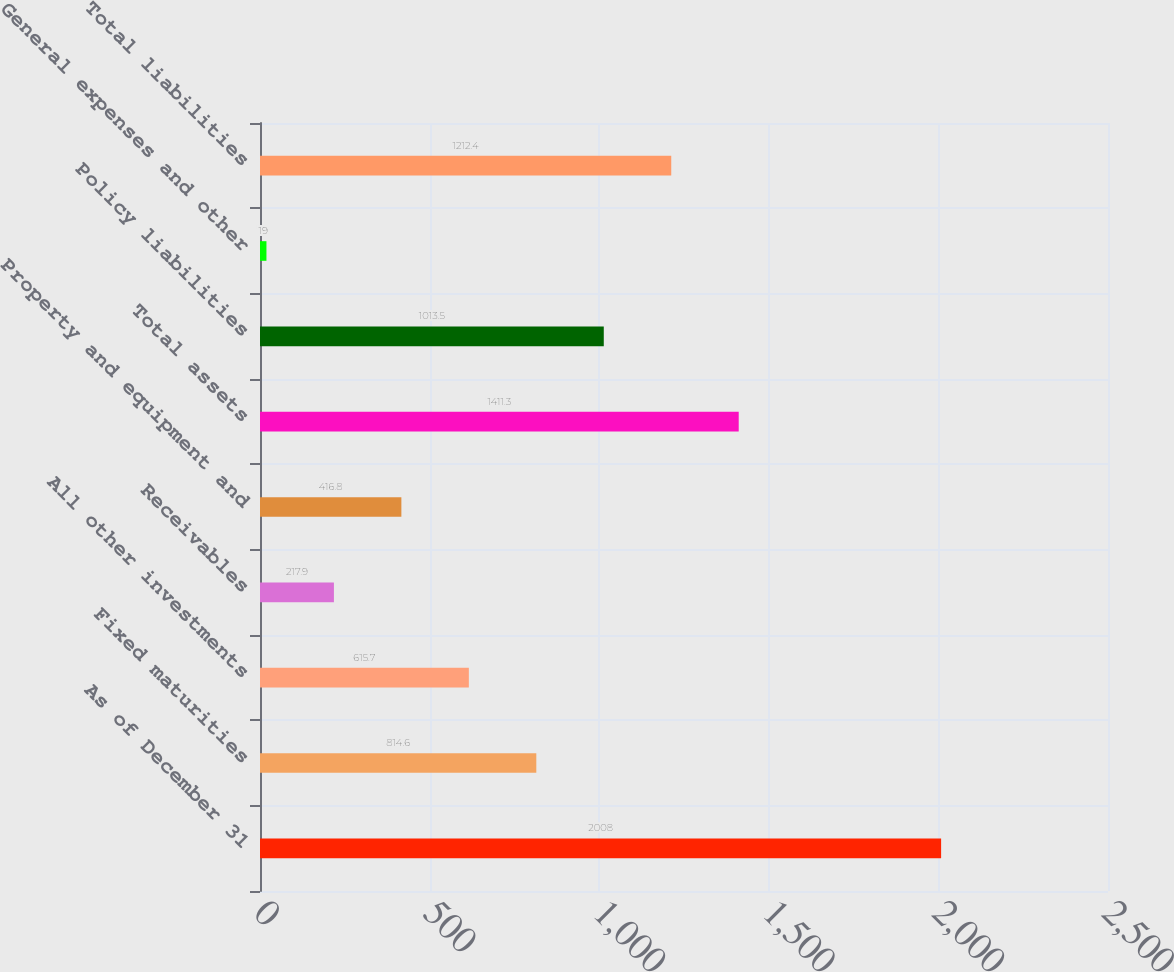Convert chart. <chart><loc_0><loc_0><loc_500><loc_500><bar_chart><fcel>As of December 31<fcel>Fixed maturities<fcel>All other investments<fcel>Receivables<fcel>Property and equipment and<fcel>Total assets<fcel>Policy liabilities<fcel>General expenses and other<fcel>Total liabilities<nl><fcel>2008<fcel>814.6<fcel>615.7<fcel>217.9<fcel>416.8<fcel>1411.3<fcel>1013.5<fcel>19<fcel>1212.4<nl></chart> 